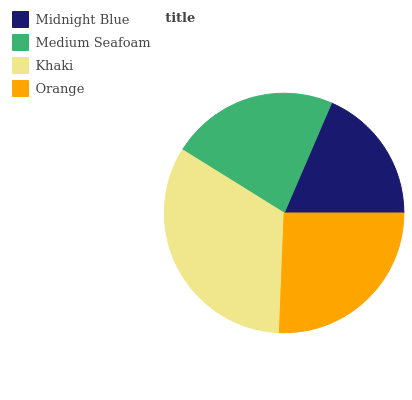Is Midnight Blue the minimum?
Answer yes or no. Yes. Is Khaki the maximum?
Answer yes or no. Yes. Is Medium Seafoam the minimum?
Answer yes or no. No. Is Medium Seafoam the maximum?
Answer yes or no. No. Is Medium Seafoam greater than Midnight Blue?
Answer yes or no. Yes. Is Midnight Blue less than Medium Seafoam?
Answer yes or no. Yes. Is Midnight Blue greater than Medium Seafoam?
Answer yes or no. No. Is Medium Seafoam less than Midnight Blue?
Answer yes or no. No. Is Orange the high median?
Answer yes or no. Yes. Is Medium Seafoam the low median?
Answer yes or no. Yes. Is Medium Seafoam the high median?
Answer yes or no. No. Is Midnight Blue the low median?
Answer yes or no. No. 